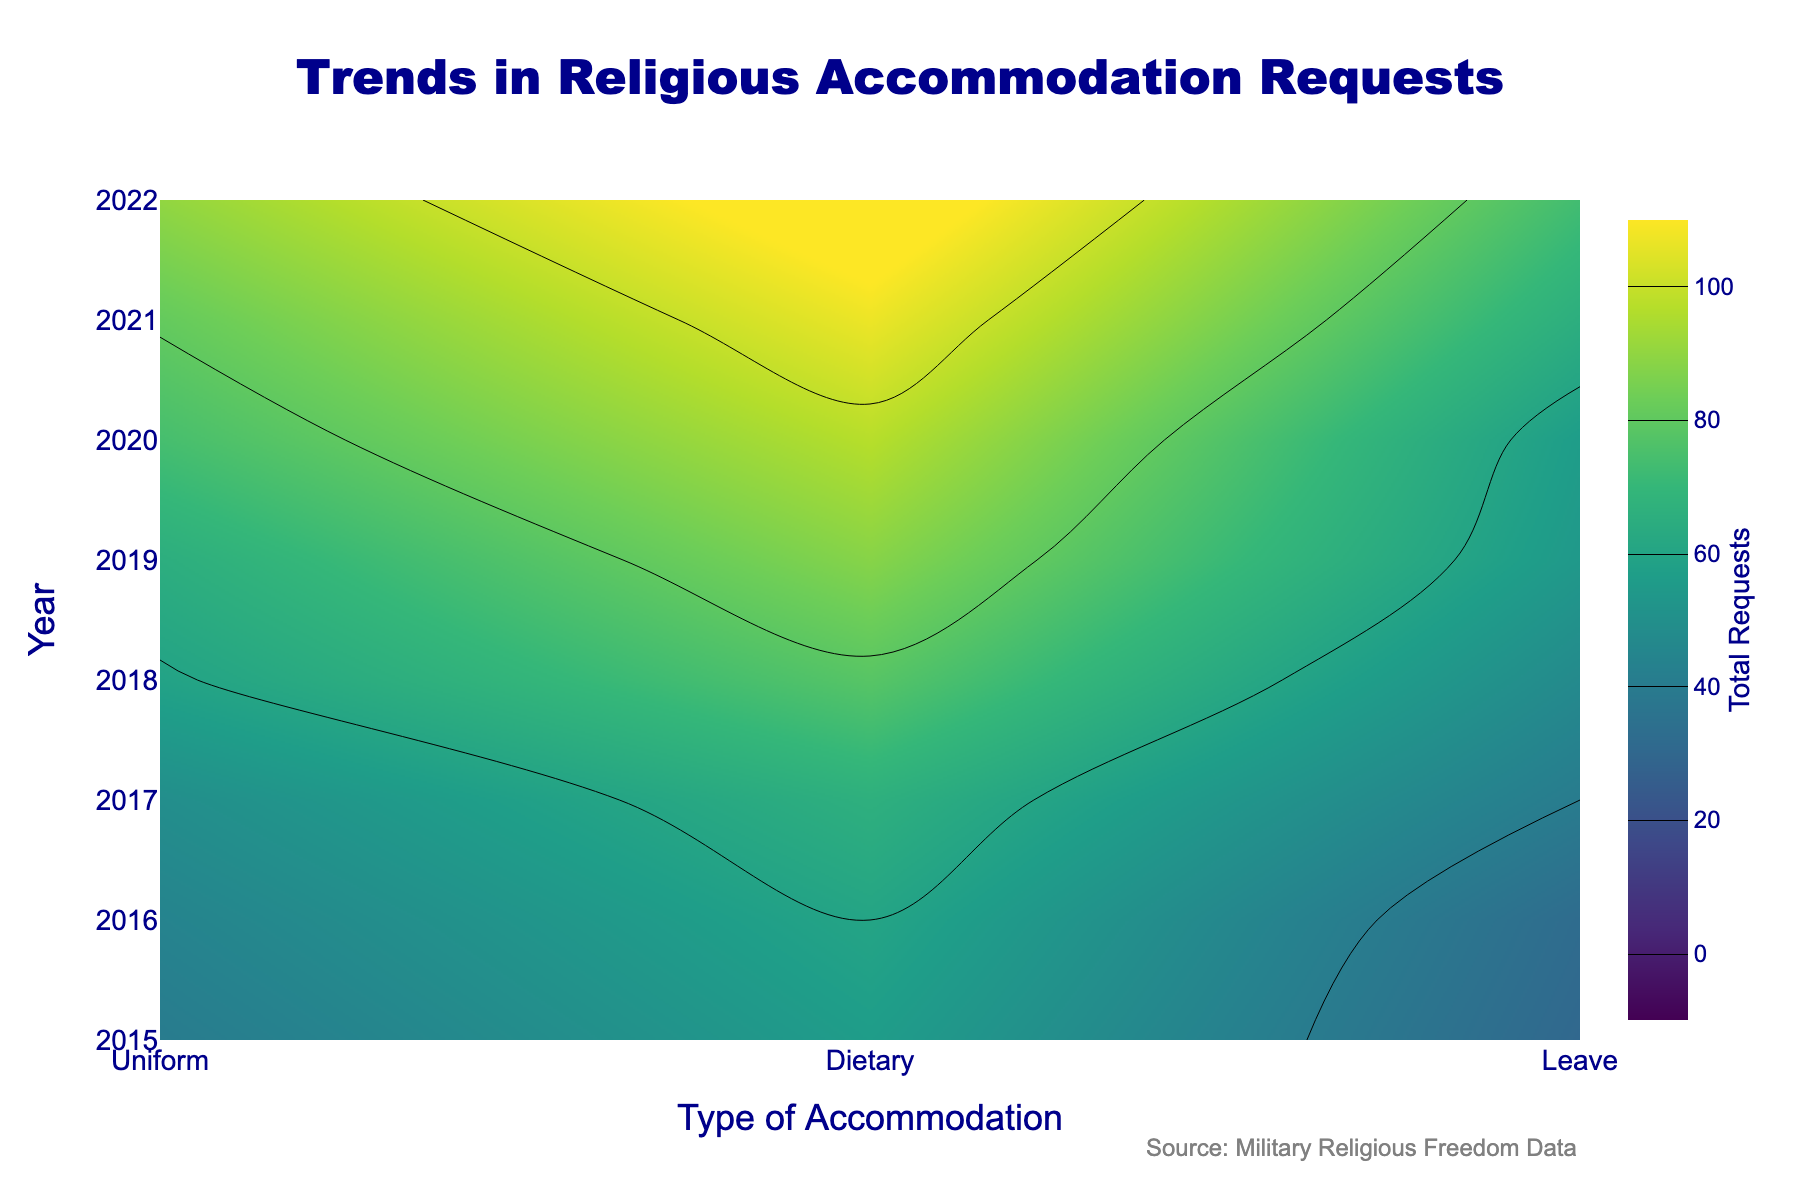what is the title of the contour plot? The title is located at the top center of the plot and provides information about the visualized data related to religious accommodations.
Answer: Trends in Religious Accommodation Requests What years does this plot cover? The years are displayed on the vertical y-axis. Reviewing it, we see it spans from 2015 to 2022.
Answer: 2015 to 2022 Which type of accommodation shows the highest frequency of requests over the years? Contour plots use colors to represent frequency, with more intense colors indicating higher frequencies. Viewing the plot closely, 'Dietary' exhibits the most intense colors across most years.
Answer: Dietary Between 2017 and 2020, which type of accommodation saw the most noticeable increase in request frequency? By examining and comparing the color intensity changes across years for each type, we notice that 'Dietary' has increased considerably in its color intensity between 2017 and 2020.
Answer: Dietary From 2015 to 2022, which accommodation type has the most consistent level of requests? Observing the contour plot for steady color intensity through the years can help determine consistent levels. 'Uniform' shows relatively consistent and somewhat increasing intensity throughout the years.
Answer: Uniform Which year saw the highest number of 'Leave' requests? By tracking the color intensities across the y-axis for 'Leave', we observe that 2022 has the brightest or highest intensity for 'Leave'.
Answer: 2022 How do the total requests for 'Uniform' and 'Dietary' in 2020 compare? Looking at the color intensity of 'Uniform' and 'Dietary' for the specific year 2020, 'Dietary' has a significantly higher intensity indicating more total requests compared to 'Uniform'.
Answer: Dietary is higher What is indicated by the colors in the contour plot? The colors on the contour plot indicate the total requests for religious accommodations, where a more intense color signifies a higher number of requests.
Answer: Total requests In which year were the total requests the least frequent regardless of type? Observing the color intensity across all types collectively, 2015 shows consistently lower intensity colors compared to other years making it the year with the least frequent requests.
Answer: 2015 